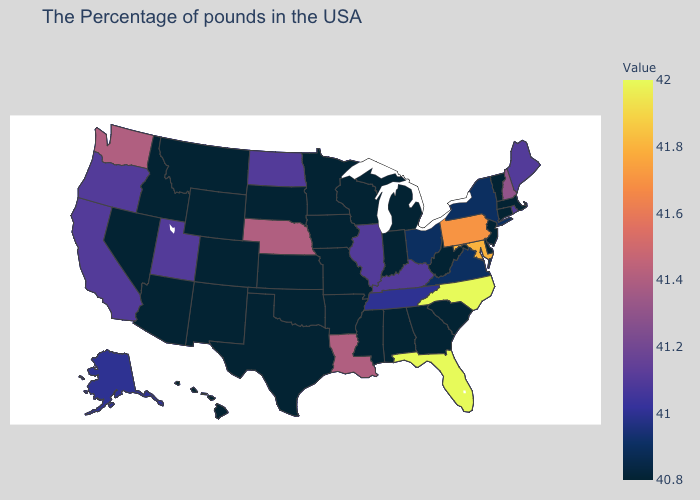Among the states that border West Virginia , does Maryland have the highest value?
Concise answer only. Yes. Among the states that border Iowa , does South Dakota have the highest value?
Keep it brief. No. Among the states that border Nevada , which have the lowest value?
Answer briefly. Arizona, Idaho. Does Florida have the highest value in the USA?
Write a very short answer. Yes. Does Massachusetts have the lowest value in the Northeast?
Concise answer only. Yes. Among the states that border Wyoming , which have the lowest value?
Write a very short answer. South Dakota, Colorado, Montana, Idaho. 